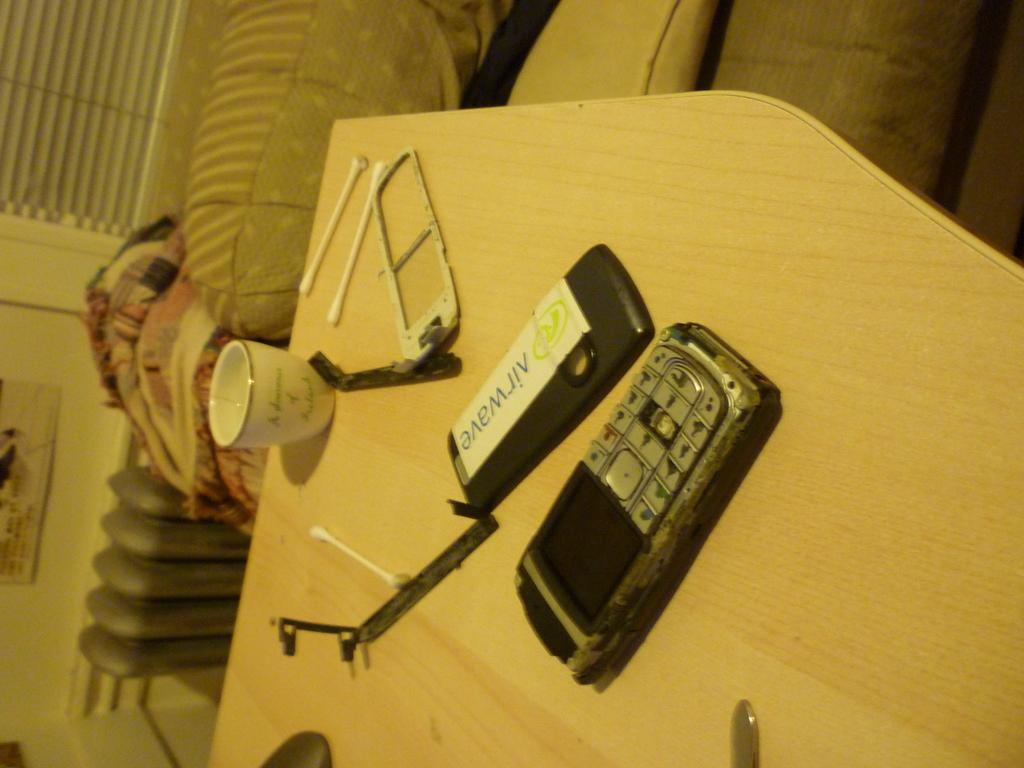<image>
Provide a brief description of the given image. a phone plastic that has a label on it that says 'airwave' on it 